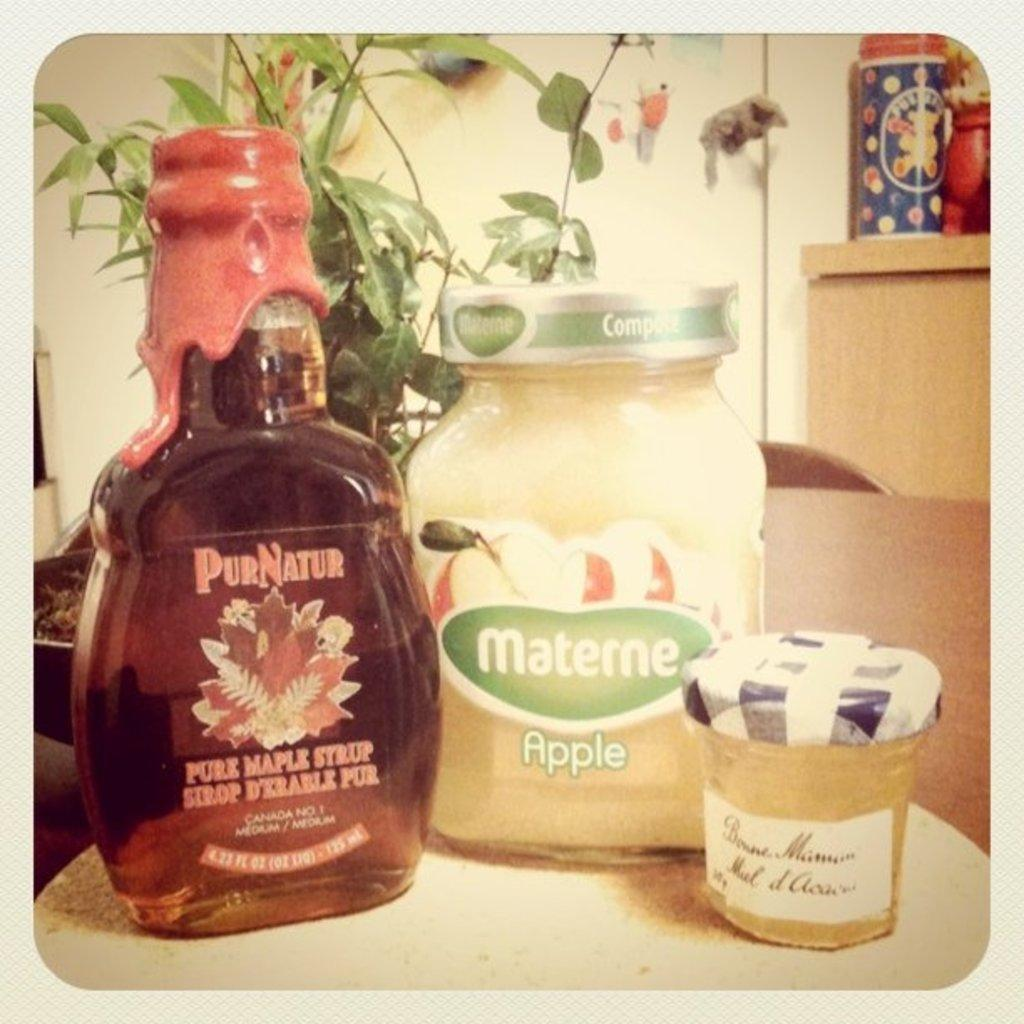<image>
Write a terse but informative summary of the picture. A bottle of PurNatur maple syrup is on a table. 